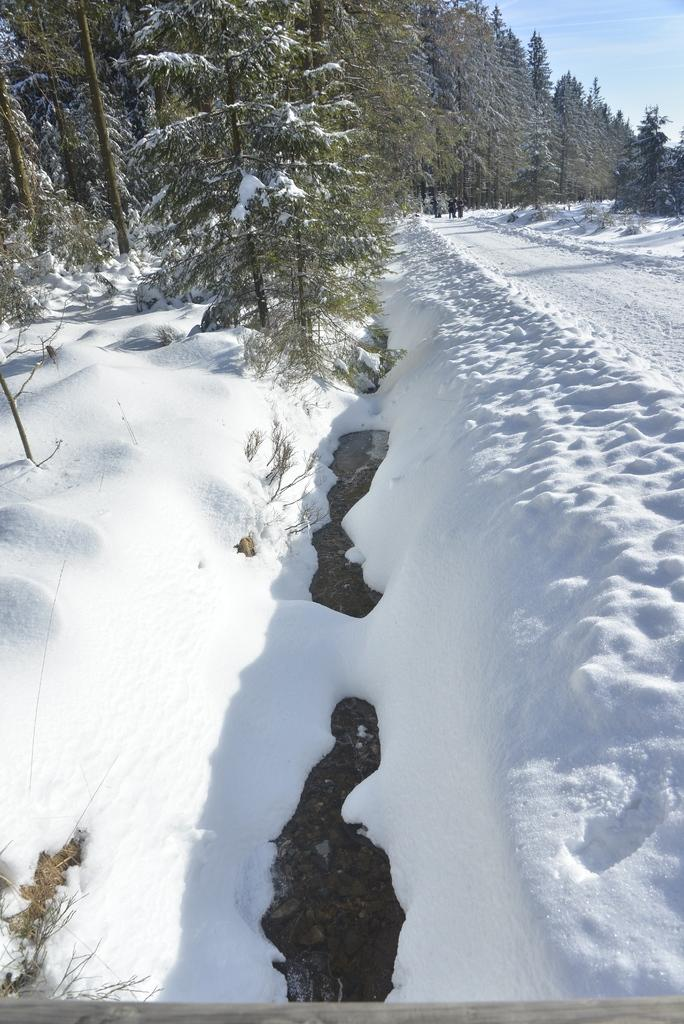What is present on the road in the image? There is ice on the road in the image. What type of natural elements can be seen in the image? There are trees in the image. Who or what is present in the image besides the trees? There is a group of people in the image. What part of the sky is visible in the image? The sky is visible in the top right corner of the image. What is the weather like in the image? The image was taken during a sunny day. What type of knife can be seen in the hands of the people in the image? There is no knife present in the image; it features a group of people on a road with ice and trees. What type of fork can be seen in the image? There is no fork present in the image. 